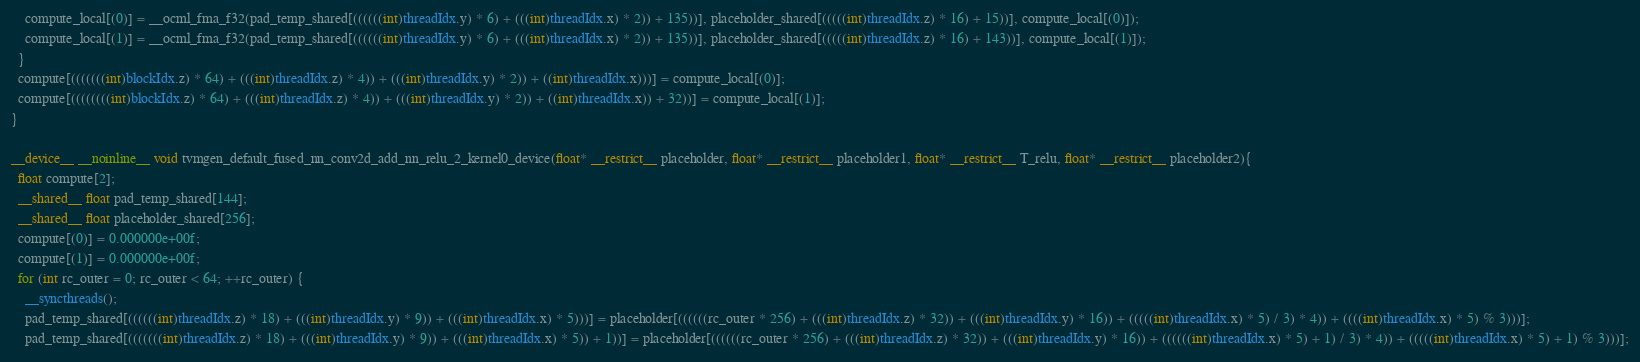Convert code to text. <code><loc_0><loc_0><loc_500><loc_500><_Cuda_>    compute_local[(0)] = __ocml_fma_f32(pad_temp_shared[((((((int)threadIdx.y) * 6) + (((int)threadIdx.x) * 2)) + 135))], placeholder_shared[(((((int)threadIdx.z) * 16) + 15))], compute_local[(0)]);
    compute_local[(1)] = __ocml_fma_f32(pad_temp_shared[((((((int)threadIdx.y) * 6) + (((int)threadIdx.x) * 2)) + 135))], placeholder_shared[(((((int)threadIdx.z) * 16) + 143))], compute_local[(1)]);
  }
  compute[(((((((int)blockIdx.z) * 64) + (((int)threadIdx.z) * 4)) + (((int)threadIdx.y) * 2)) + ((int)threadIdx.x)))] = compute_local[(0)];
  compute[((((((((int)blockIdx.z) * 64) + (((int)threadIdx.z) * 4)) + (((int)threadIdx.y) * 2)) + ((int)threadIdx.x)) + 32))] = compute_local[(1)];
}

__device__ __noinline__ void tvmgen_default_fused_nn_conv2d_add_nn_relu_2_kernel0_device(float* __restrict__ placeholder, float* __restrict__ placeholder1, float* __restrict__ T_relu, float* __restrict__ placeholder2){
  float compute[2];
  __shared__ float pad_temp_shared[144];
  __shared__ float placeholder_shared[256];
  compute[(0)] = 0.000000e+00f;
  compute[(1)] = 0.000000e+00f;
  for (int rc_outer = 0; rc_outer < 64; ++rc_outer) {
    __syncthreads();
    pad_temp_shared[((((((int)threadIdx.z) * 18) + (((int)threadIdx.y) * 9)) + (((int)threadIdx.x) * 5)))] = placeholder[((((((rc_outer * 256) + (((int)threadIdx.z) * 32)) + (((int)threadIdx.y) * 16)) + (((((int)threadIdx.x) * 5) / 3) * 4)) + ((((int)threadIdx.x) * 5) % 3)))];
    pad_temp_shared[(((((((int)threadIdx.z) * 18) + (((int)threadIdx.y) * 9)) + (((int)threadIdx.x) * 5)) + 1))] = placeholder[((((((rc_outer * 256) + (((int)threadIdx.z) * 32)) + (((int)threadIdx.y) * 16)) + ((((((int)threadIdx.x) * 5) + 1) / 3) * 4)) + (((((int)threadIdx.x) * 5) + 1) % 3)))];</code> 